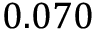<formula> <loc_0><loc_0><loc_500><loc_500>0 . 0 7 0</formula> 